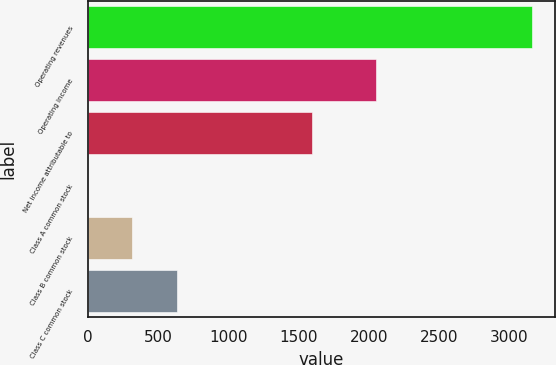<chart> <loc_0><loc_0><loc_500><loc_500><bar_chart><fcel>Operating revenues<fcel>Operating income<fcel>Net income attributable to<fcel>Class A common stock<fcel>Class B common stock<fcel>Class C common stock<nl><fcel>3163<fcel>2048<fcel>1598<fcel>0.63<fcel>316.87<fcel>633.11<nl></chart> 